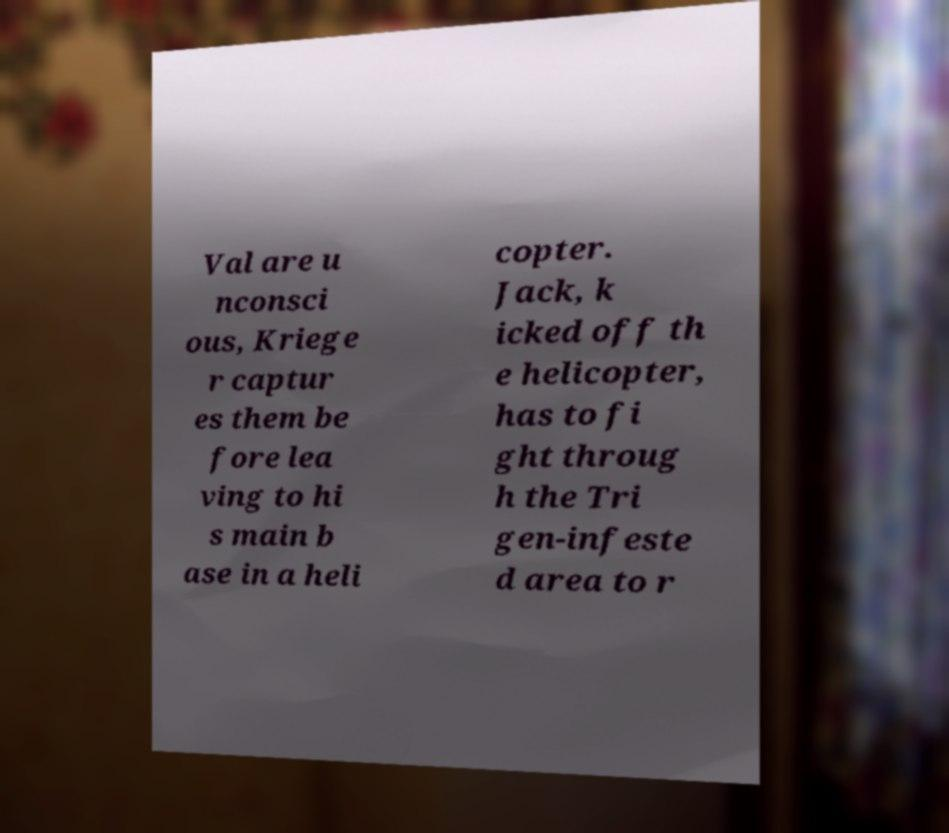There's text embedded in this image that I need extracted. Can you transcribe it verbatim? Val are u nconsci ous, Kriege r captur es them be fore lea ving to hi s main b ase in a heli copter. Jack, k icked off th e helicopter, has to fi ght throug h the Tri gen-infeste d area to r 